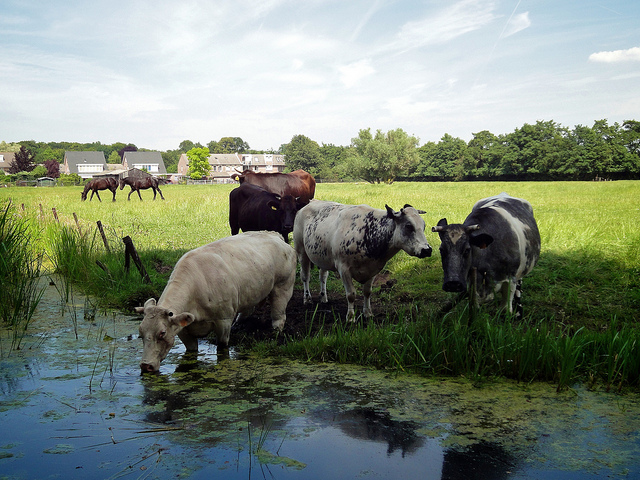<image>What is dividing the water and grass? I am not sure what is dividing the water and grass. It could be a fence, algae, or plants. What is dividing the water and grass? I don't know what is dividing the water and grass. It can be fence or plants. 